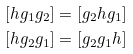Convert formula to latex. <formula><loc_0><loc_0><loc_500><loc_500>[ h g _ { 1 } g _ { 2 } ] = [ g _ { 2 } h g _ { 1 } ] \\ [ h g _ { 2 } g _ { 1 } ] = [ g _ { 2 } g _ { 1 } h ]</formula> 